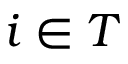Convert formula to latex. <formula><loc_0><loc_0><loc_500><loc_500>i \in T</formula> 